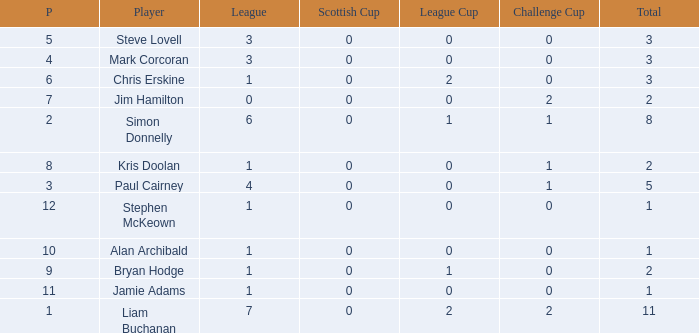What was the lowest number of points scored in the league cup? 0.0. Give me the full table as a dictionary. {'header': ['P', 'Player', 'League', 'Scottish Cup', 'League Cup', 'Challenge Cup', 'Total'], 'rows': [['5', 'Steve Lovell', '3', '0', '0', '0', '3'], ['4', 'Mark Corcoran', '3', '0', '0', '0', '3'], ['6', 'Chris Erskine', '1', '0', '2', '0', '3'], ['7', 'Jim Hamilton', '0', '0', '0', '2', '2'], ['2', 'Simon Donnelly', '6', '0', '1', '1', '8'], ['8', 'Kris Doolan', '1', '0', '0', '1', '2'], ['3', 'Paul Cairney', '4', '0', '0', '1', '5'], ['12', 'Stephen McKeown', '1', '0', '0', '0', '1'], ['10', 'Alan Archibald', '1', '0', '0', '0', '1'], ['9', 'Bryan Hodge', '1', '0', '1', '0', '2'], ['11', 'Jamie Adams', '1', '0', '0', '0', '1'], ['1', 'Liam Buchanan', '7', '0', '2', '2', '11']]} 